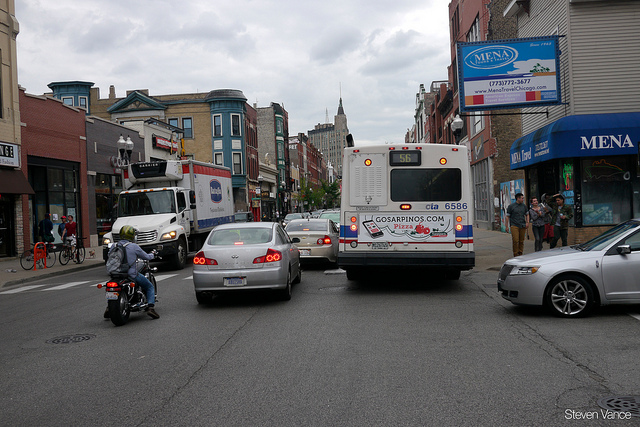Identify and read out the text in this image. MENA MENA 56 V Steven 6586 GOSARPINOS.COM 